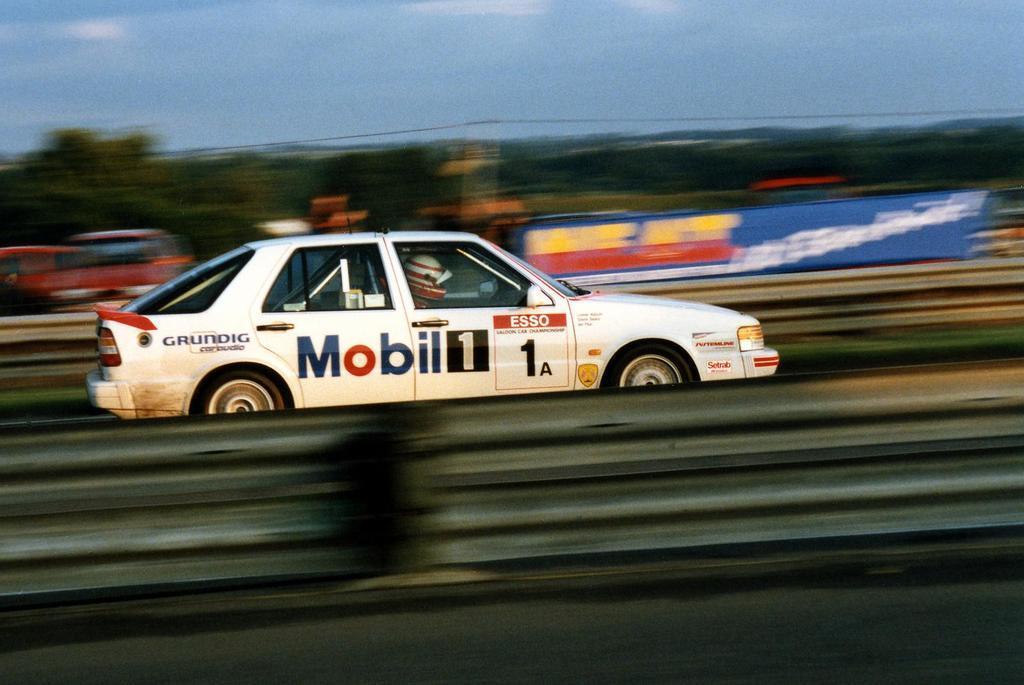How would you summarize this image in a sentence or two? In this picture I can see there is a person driving a car and he is wearing a helmet and the image is blurry and it looks like a blue banner and there are few trees and the sky is clear. 